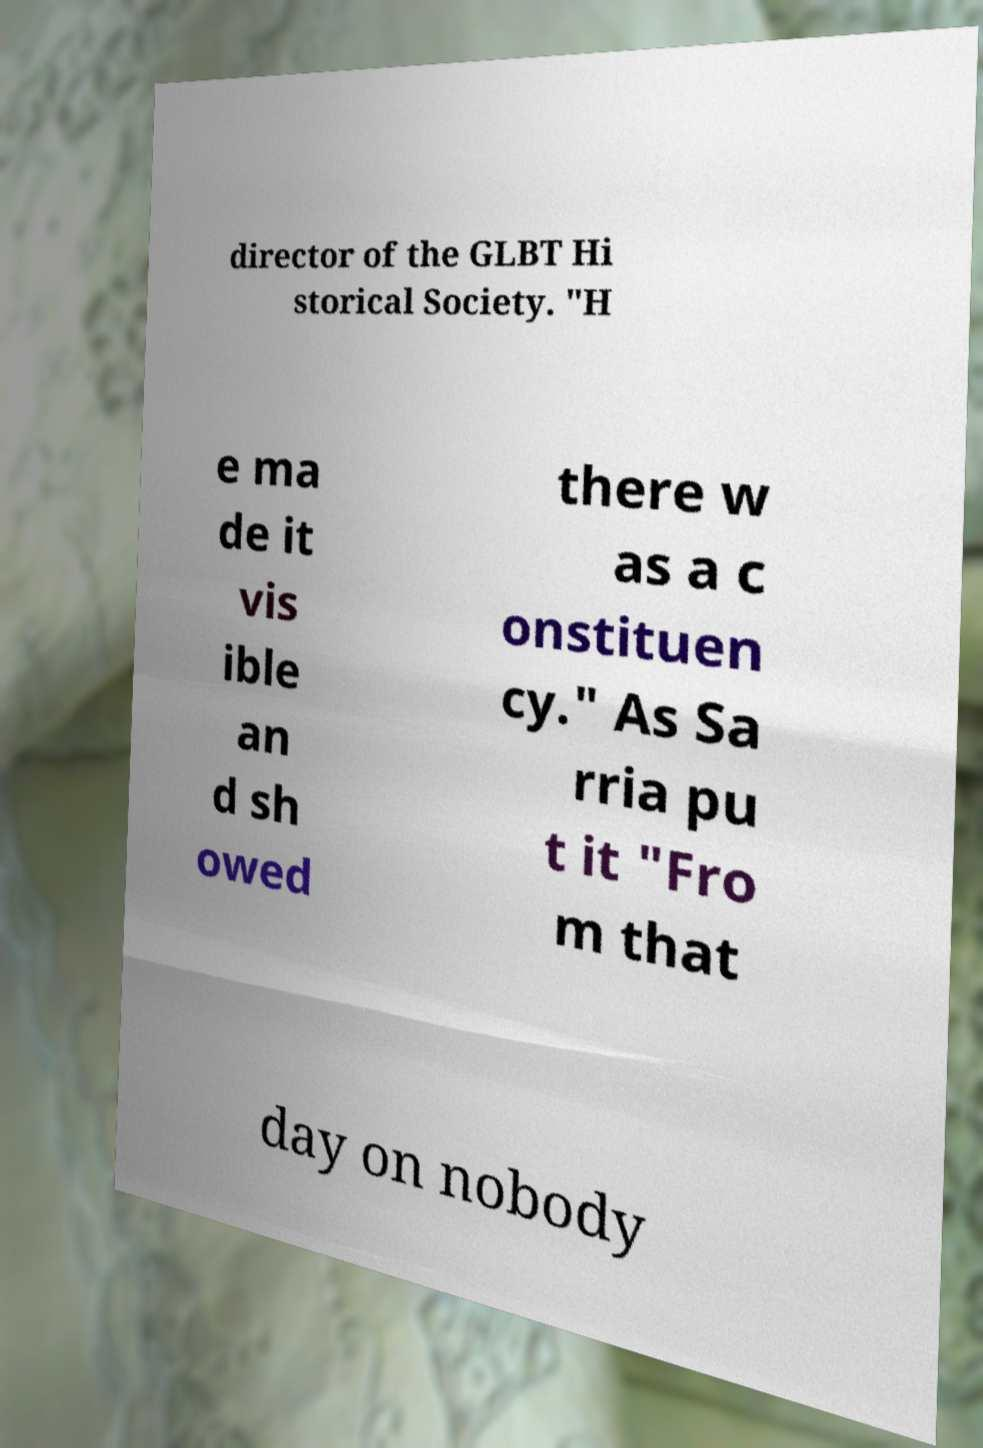For documentation purposes, I need the text within this image transcribed. Could you provide that? director of the GLBT Hi storical Society. "H e ma de it vis ible an d sh owed there w as a c onstituen cy." As Sa rria pu t it "Fro m that day on nobody 